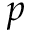Convert formula to latex. <formula><loc_0><loc_0><loc_500><loc_500>p</formula> 